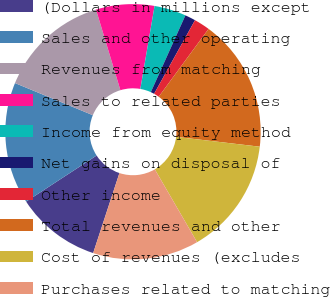Convert chart. <chart><loc_0><loc_0><loc_500><loc_500><pie_chart><fcel>(Dollars in millions except<fcel>Sales and other operating<fcel>Revenues from matching<fcel>Sales to related parties<fcel>Income from equity method<fcel>Net gains on disposal of<fcel>Other income<fcel>Total revenues and other<fcel>Cost of revenues (excludes<fcel>Purchases related to matching<nl><fcel>10.74%<fcel>15.44%<fcel>14.09%<fcel>7.38%<fcel>4.03%<fcel>1.34%<fcel>2.01%<fcel>16.78%<fcel>14.76%<fcel>13.42%<nl></chart> 